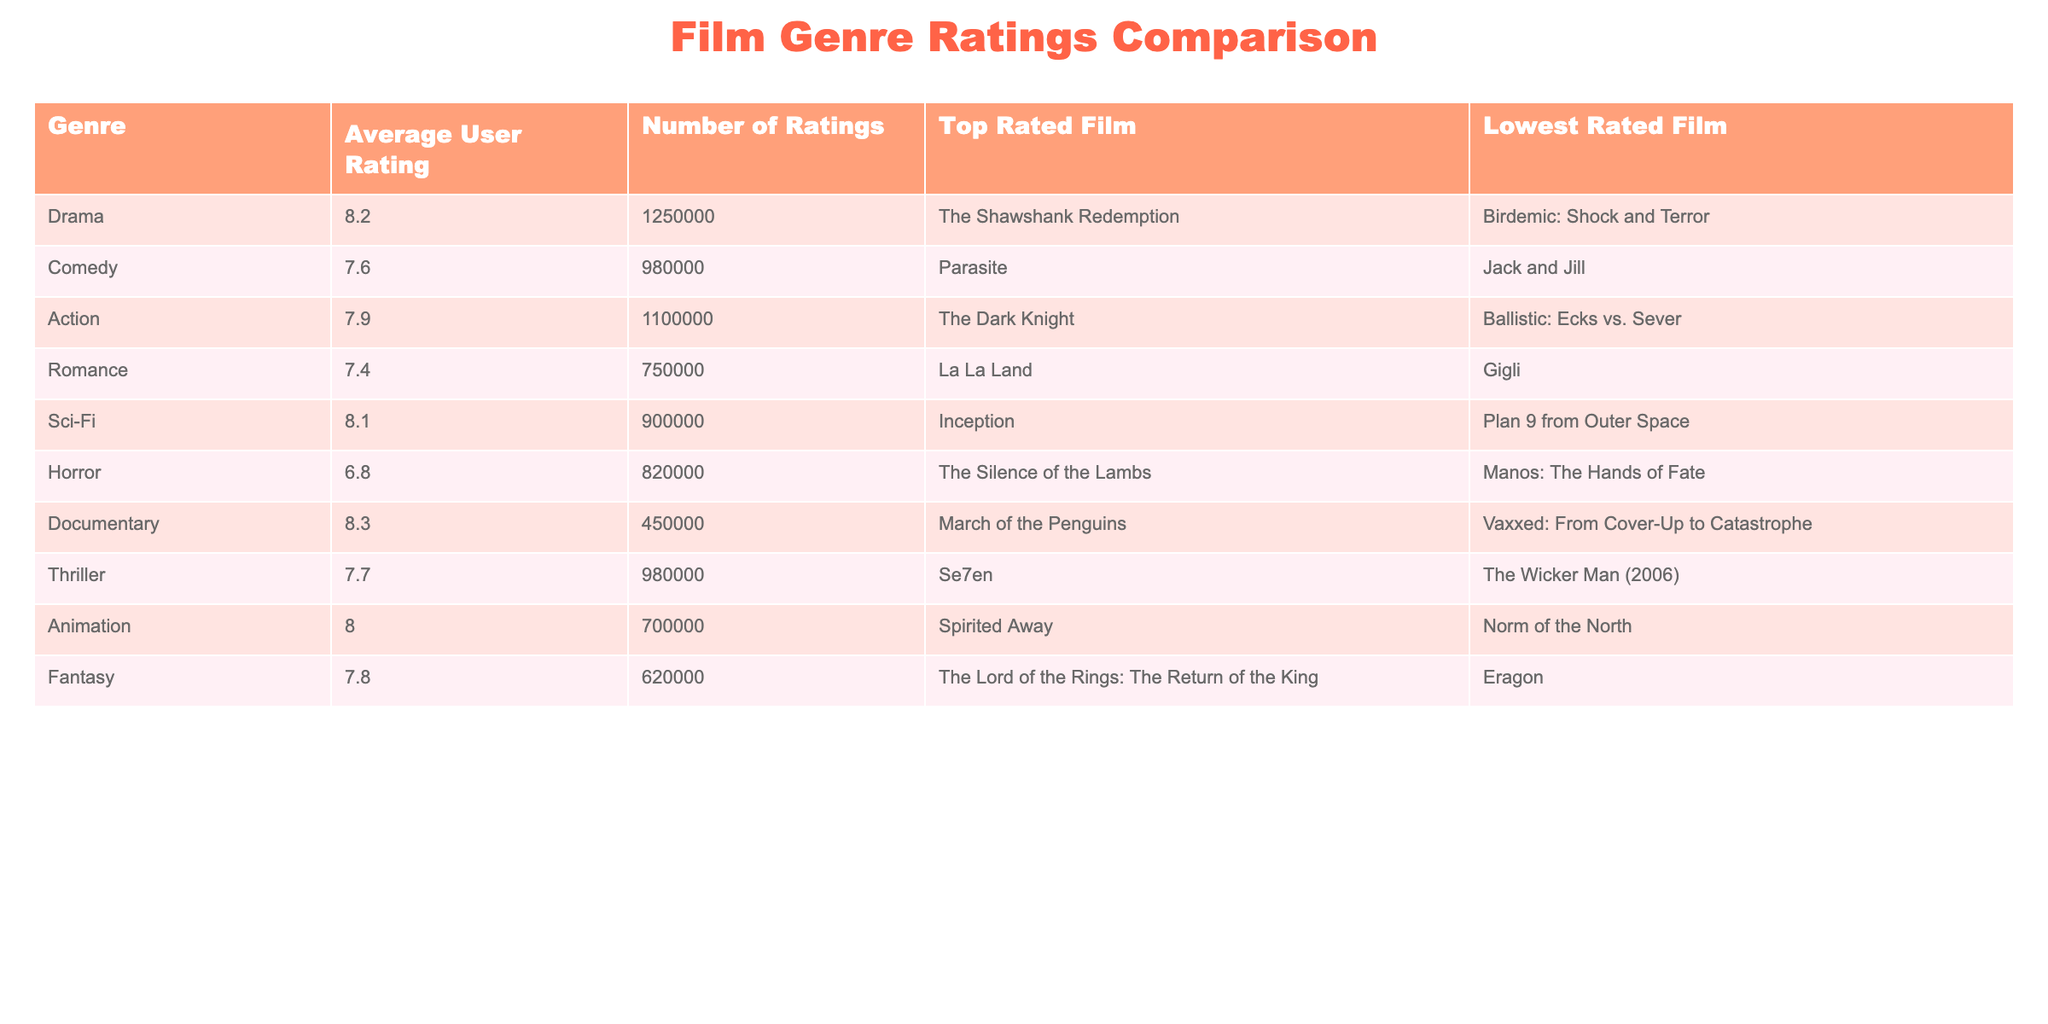What is the average user rating for the Documentary genre? The table shows that the average user rating for the Documentary genre is listed as 8.3.
Answer: 8.3 Which genre has the highest average user rating? By examining the average user ratings for all genres listed, Documentary has the highest average rating at 8.3.
Answer: Documentary How many ratings were given for Comedy films? The table indicates that Comedy films received a total of 980,000 ratings.
Answer: 980,000 What is the lowest rated film in the Action genre? According to the table, the lowest rated film in the Action genre is Ballistic: Ecks vs. Sever.
Answer: Ballistic: Ecks vs. Sever Is the average user rating for Horror films higher than that for Romance films? The average user rating for Horror films is 6.8, while for Romance films, it is 7.4. Since 6.8 is not higher than 7.4, the answer is no.
Answer: No What is the difference in average user ratings between Sci-Fi and Animation genres? The average user rating for Sci-Fi is 8.1 and for Animation it is 8.0. The difference is 8.1 - 8.0 = 0.1.
Answer: 0.1 Which film received the highest rating in the Drama genre? The table shows that the highest-rated film in the Drama genre is The Shawshank Redemption.
Answer: The Shawshank Redemption What is the total number of ratings for both the Thriller and Comedy genres combined? The number of ratings for Thriller is 980,000, and for Comedy is 980,000 as well. Therefore, the combined total is 980,000 + 980,000 = 1,960,000.
Answer: 1,960,000 Which genre has the lowest average user rating? As per the table, the Horror genre has the lowest average user rating at 6.8.
Answer: Horror Is there a genre with an average rating of 8.0 among those listed? Reviewing the table, Animation is the only genre listed with an average rating of 8.0.
Answer: Yes 